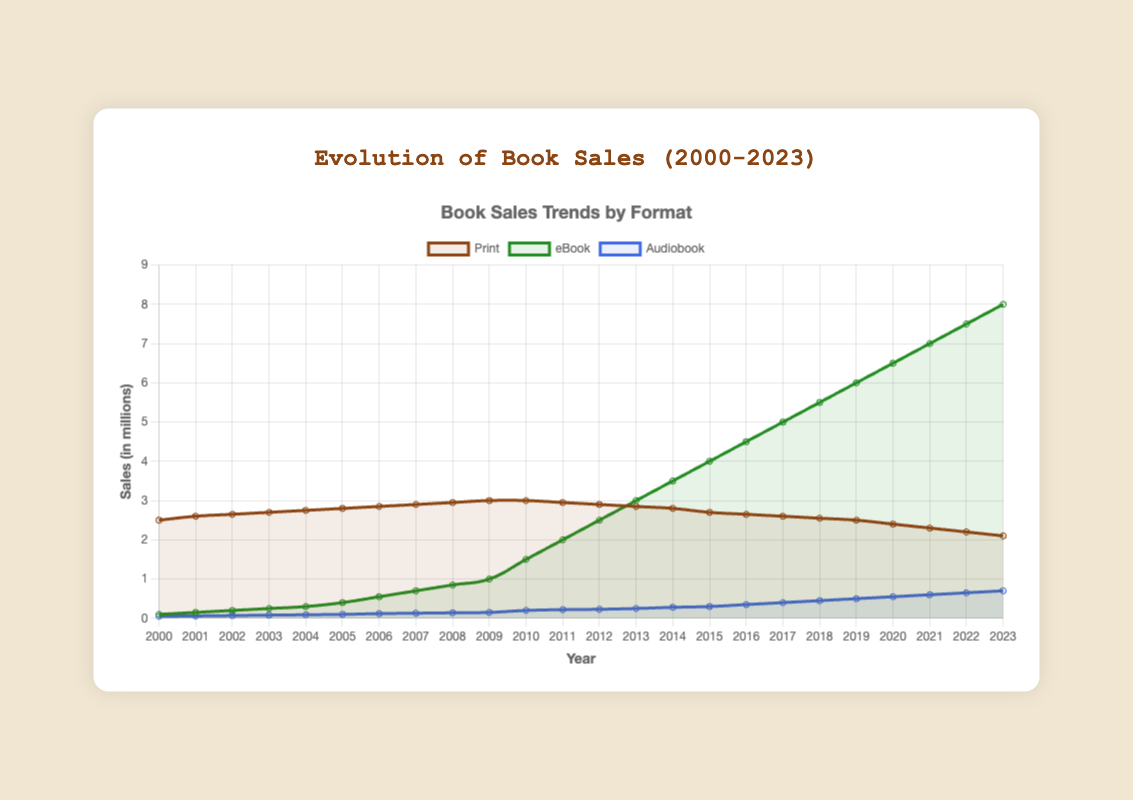What trend can be observed for print book sales from 2000 to 2023? Print book sales have gradually increased from 2.5 million in 2000 to a peak of 3.0 million in 2009 and 2010 before declining to 2.1 million in 2023.
Answer: Decreasing Between which years did eBook sales see the most rapid increase? From 2008 to 2010, eBook sales increased from 0.85 million to 1.5 million.
Answer: 2008 to 2010 How do audiobook sales in 2023 compare to those in 2000? Audiobook sales have increased continuously from 0.05 million in 2000 to 0.7 million in 2023, indicating a significant growth.
Answer: Increased What is the total summed sales of all three formats in 2020? Print: 2.4 million, eBook: 6.5 million, Audiobook: 0.55 million, summing to 2.4 + 6.5 + 0.55 = 9.45 million.
Answer: 9.45 million What format has shown the most consistent growth across the years? The eBook format has shown consistent growth from 0.1 million in 2000 to 8.0 million in 2023 without any significant drops.
Answer: eBook How does the peak print book sales compare to the peak eBook sales? The peak print sales are 3.0 million in 2009 and 2010, whereas the peak eBook sales are 8.0 million in 2023.
Answer: eBook sales are higher When did audiobook sales first surpass 0.5 million? Audiobook sales first surpassed 0.5 million in 2019 with sales of 0.5 million.
Answer: 2019 What are the visual differences in trends for print books compared to eBooks? Print books show a peak followed by a decline, while eBooks show a steady, significant upward trend.
Answer: Print peaks and declines; eBooks rise What is the difference in sales between eBooks and audiobooks in 2010? eBook sales in 2010: 1.5 million, Audiobook sales in 2010: 0.2 million, difference: 1.5 - 0.2 = 1.3 million.
Answer: 1.3 million Between which years did print sales remain stable without significant change? From 2009 to 2010, print sales remained stable at 3.0 million.
Answer: 2009-2010 